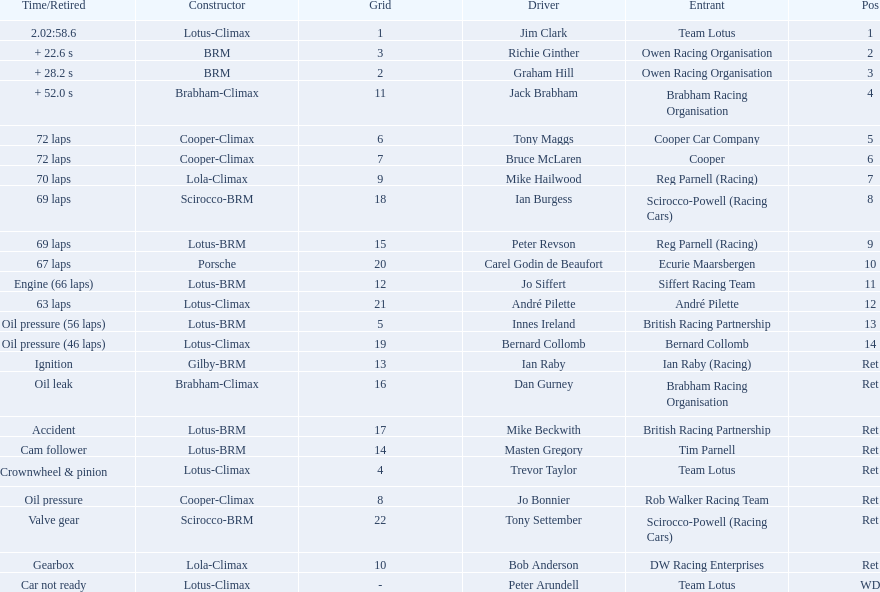Who are all the drivers? Jim Clark, Richie Ginther, Graham Hill, Jack Brabham, Tony Maggs, Bruce McLaren, Mike Hailwood, Ian Burgess, Peter Revson, Carel Godin de Beaufort, Jo Siffert, André Pilette, Innes Ireland, Bernard Collomb, Ian Raby, Dan Gurney, Mike Beckwith, Masten Gregory, Trevor Taylor, Jo Bonnier, Tony Settember, Bob Anderson, Peter Arundell. What were their positions? 1, 2, 3, 4, 5, 6, 7, 8, 9, 10, 11, 12, 13, 14, Ret, Ret, Ret, Ret, Ret, Ret, Ret, Ret, WD. What are all the constructor names? Lotus-Climax, BRM, BRM, Brabham-Climax, Cooper-Climax, Cooper-Climax, Lola-Climax, Scirocco-BRM, Lotus-BRM, Porsche, Lotus-BRM, Lotus-Climax, Lotus-BRM, Lotus-Climax, Gilby-BRM, Brabham-Climax, Lotus-BRM, Lotus-BRM, Lotus-Climax, Cooper-Climax, Scirocco-BRM, Lola-Climax, Lotus-Climax. And which drivers drove a cooper-climax? Tony Maggs, Bruce McLaren. Between those tow, who was positioned higher? Tony Maggs. 